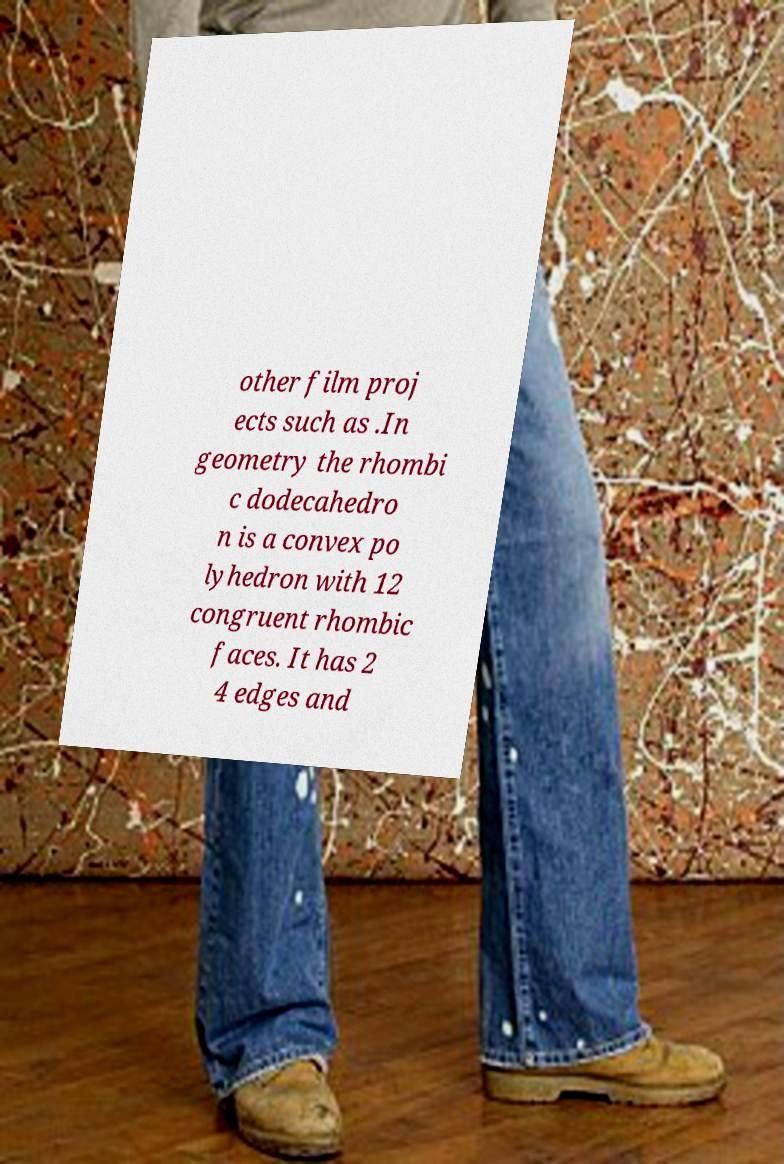What messages or text are displayed in this image? I need them in a readable, typed format. other film proj ects such as .In geometry the rhombi c dodecahedro n is a convex po lyhedron with 12 congruent rhombic faces. It has 2 4 edges and 